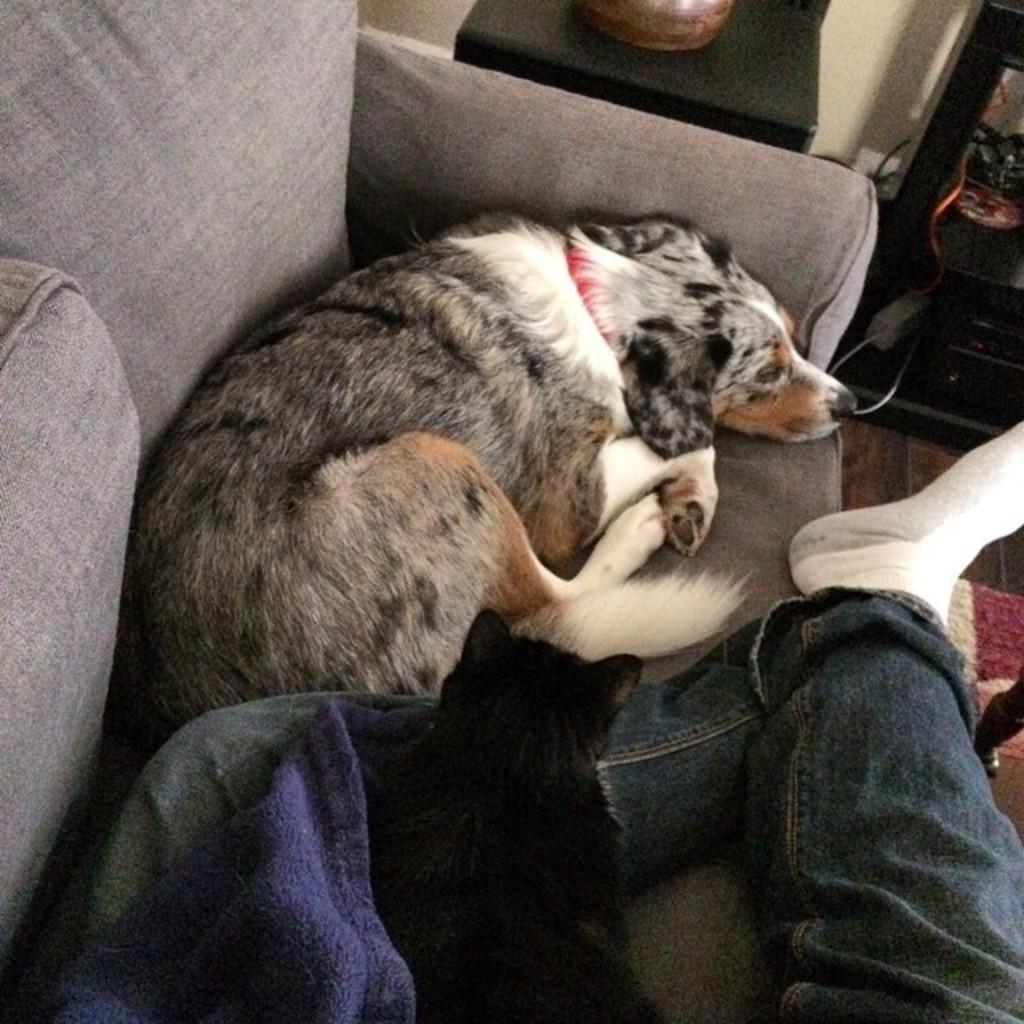How would you summarize this image in a sentence or two? There is a sofa and there is a cat and a dog laying on a sofa. The cat is laying on the leg of a person and beside the sofa there is a table. In the background there is a wall. 